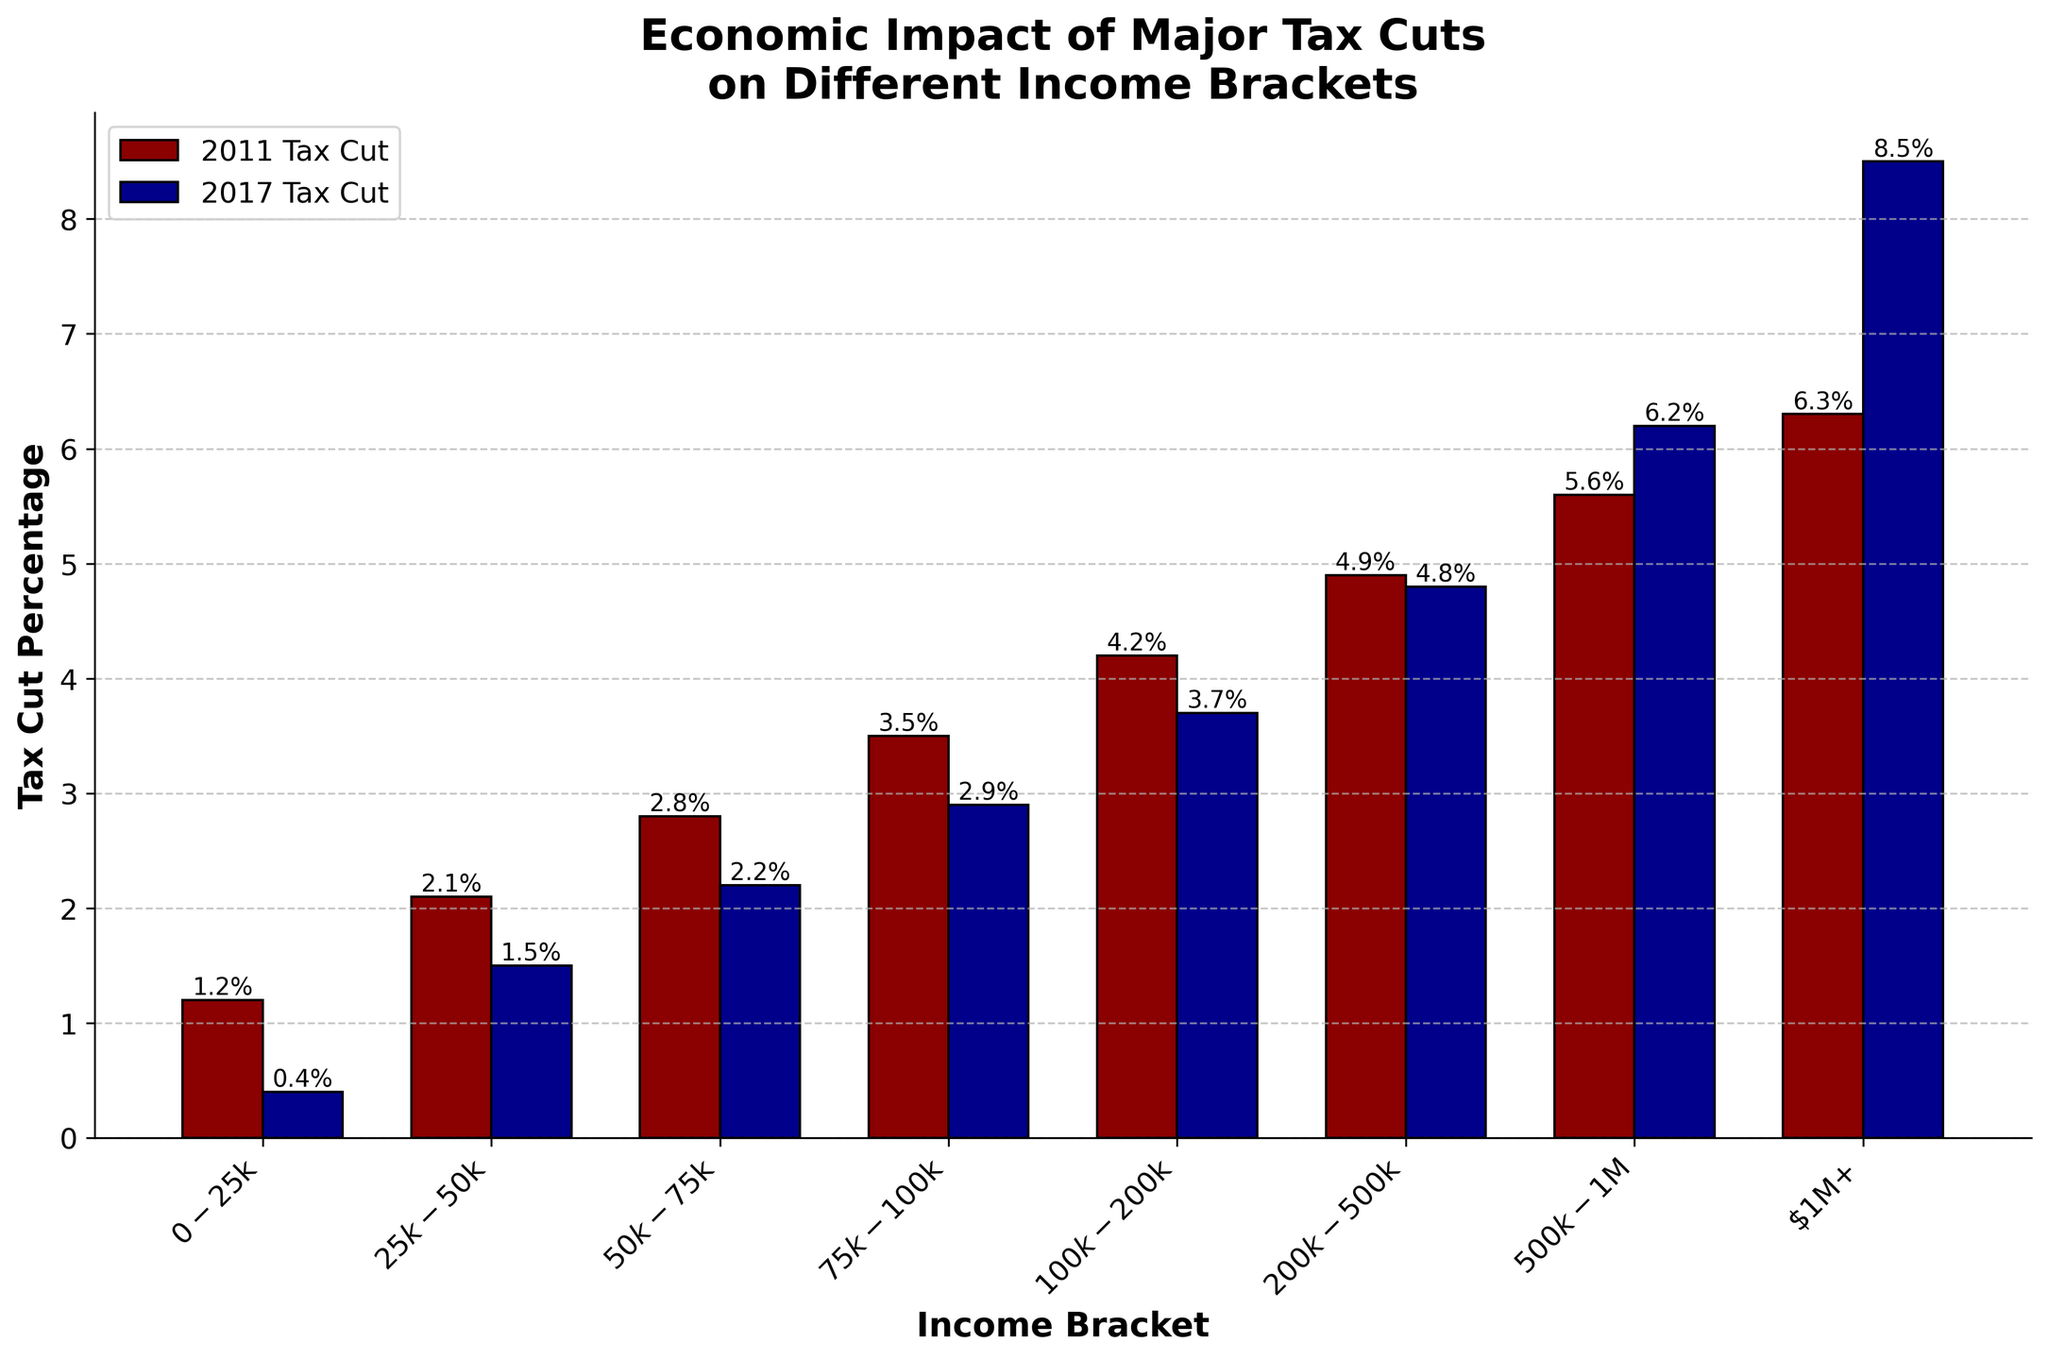What is the difference in tax cut percentage between 2011 and 2017 for the income bracket $50k-$75k? In 2011, the tax cut for $50k-$75k bracket was 2.8%. In 2017, it was 2.2%. Subtracting the two gives 2.8% - 2.2% = 0.6%.
Answer: 0.6% Which income bracket experienced the largest increase in tax cut percentage from 2011 to 2017? Look for the income bracket with the greatest difference between the 2011 and 2017 tax cuts. The $1M+ bracket increased from 6.3% to 8.5%, which is the largest increase (8.5% - 6.3% = 2.2%).
Answer: $1M+ What is the average tax cut percentage across all income brackets in 2011? Add all the tax cuts for 2011 and then divide by the number of brackets: (1.2% + 2.1% + 2.8% + 3.5% + 4.2% + 4.9% + 5.6% + 6.3%) / 8 = 30.6% / 8 = 3.825%.
Answer: 3.825% Which income bracket has the smallest tax cut percentage in 2017? The smallest bar in 2017 corresponds to the $0-$25k bracket with a tax cut of 0.4%.
Answer: $0-$25k How much greater is the tax cut percentage for the $200k-$500k bracket compared to the $25k-$50k bracket in 2017? The tax cut for $200k-$500k is 4.8% and for $25k-$50k is 1.5%. Subtracting the two gives 4.8% - 1.5% = 3.3%.
Answer: 3.3% By how much did the tax cut percentage increase for the income bracket $500k-$1M from 2011 to 2017? In 2011, the tax cut for $500k-$1M was 5.6%. In 2017, it was 6.2%. The increase is 6.2% - 5.6% = 0.6%.
Answer: 0.6% What is the cumulative tax cut percentage for the $75k-$100k and $100k-$200k brackets in 2011? Add the tax cuts for $75k-$100k (3.5%) and $100k-$200k (4.2%) for 2011: 3.5% + 4.2% = 7.7%.
Answer: 7.7% Which tax cut was higher for the $100k-$200k income bracket: 2011 or 2017? By how much? In 2011, the tax cut for $100k-$200k was 4.2%. In 2017, it was 3.7%. The 2011 tax cut was higher by 4.2% - 3.7% = 0.5%.
Answer: 2011, 0.5% Which color represents the 2011 Tax Cut? The 2011 Tax Cut is represented by red bars in the chart.
Answer: Red What is the sum of the tax cut percentages for all income brackets in 2017? Add all the tax cuts for 2017: 0.4% + 1.5% + 2.2% + 2.9% + 3.7% + 4.8% + 6.2% + 8.5% = 30.2%.
Answer: 30.2% 